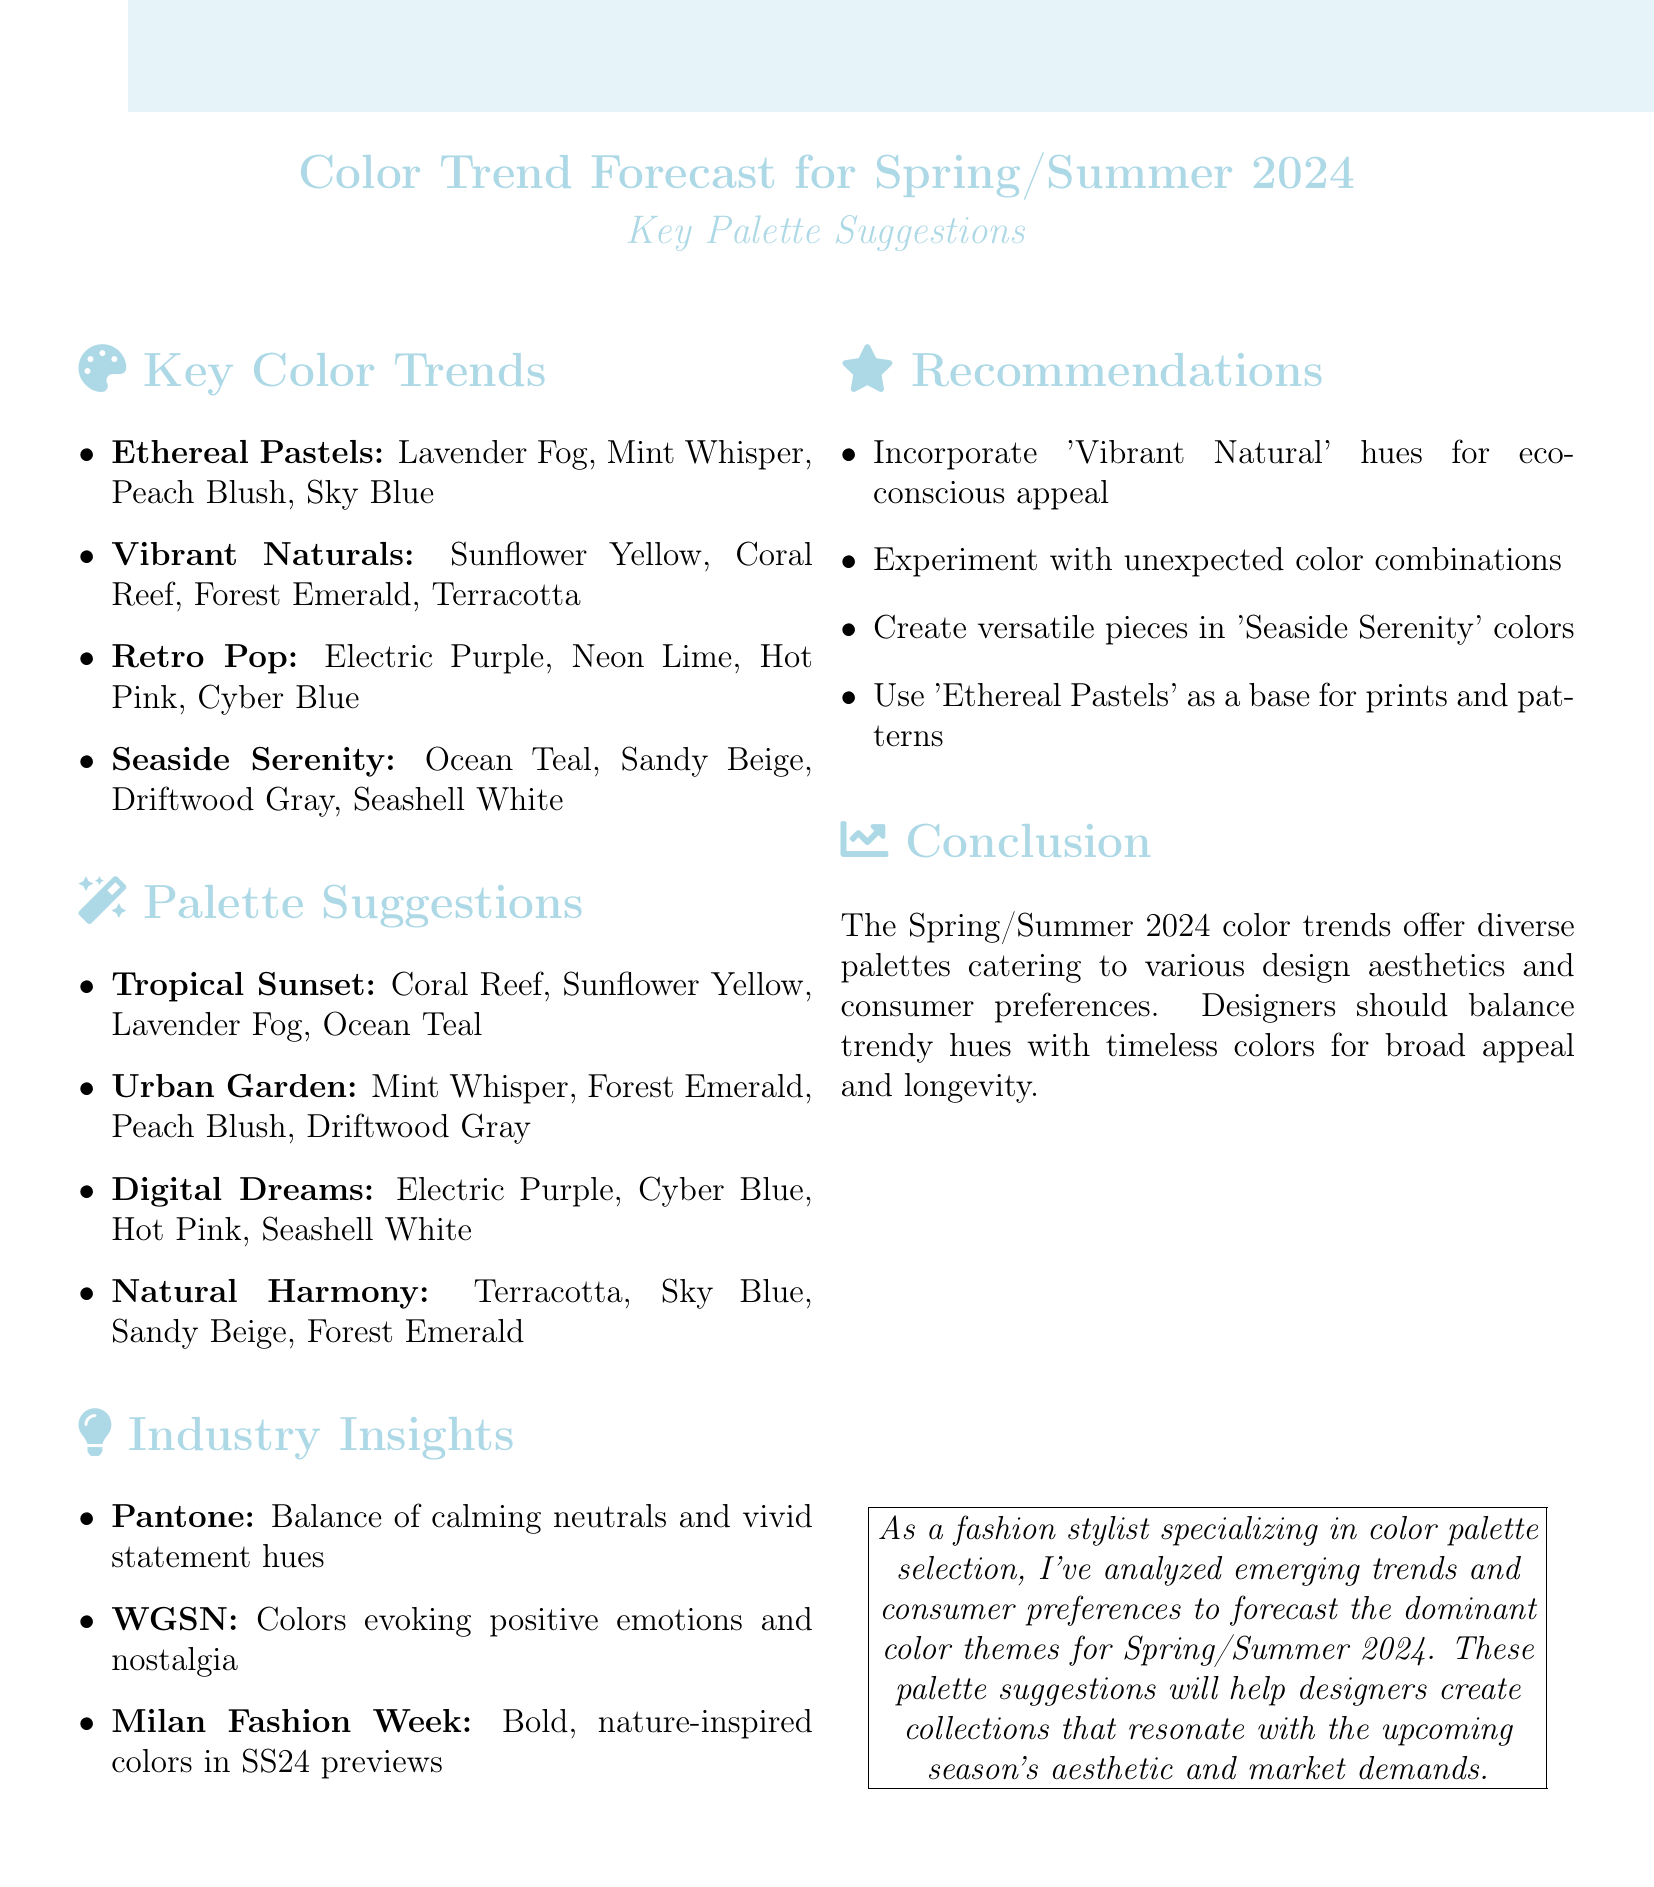What are the key color trends for Spring/Summer 2024? The document lists four key color trends: Ethereal Pastels, Vibrant Naturals, Retro Pop, and Seaside Serenity.
Answer: Ethereal Pastels, Vibrant Naturals, Retro Pop, Seaside Serenity What colors are included in the "Ethereal Pastels" trend? The document specifies that "Ethereal Pastels" includes Lavender Fog, Mint Whisper, Peach Blush, and Sky Blue.
Answer: Lavender Fog, Mint Whisper, Peach Blush, Sky Blue What is the name of the palette suitable for resort wear? The document indicates that the "Tropical Sunset" palette is suitable for resort wear, as listed in the palette suggestions.
Answer: Tropical Sunset How many palette suggestions are mentioned in the document? The document outlines a total of four palette suggestions: Tropical Sunset, Urban Garden, Digital Dreams, and Natural Harmony.
Answer: Four Which industry source mentions the balance of calming neutrals and vivid statement hues? According to the document, this insight comes from the Pantone Color Institute regarding the Spring/Summer 2024 color palette.
Answer: Pantone Color Institute What type of fashion should incorporate at least one "Vibrant Natural" hue? The recommendations emphasize appealing to the growing eco-conscious consumer base, suggesting sustainable fashion lines.
Answer: Sustainable fashion lines What nostalgic theme is reflected in one of the color trends? The document mentions that the "Retro Pop" trend is nostalgic, inspired by the 1980s and 1990s.
Answer: Retro Pop Which palette includes colors inspired by coastal landscapes? The document states that the "Seaside Serenity" palette is inspired by coastal landscapes with cool, calming tones.
Answer: Seaside Serenity 